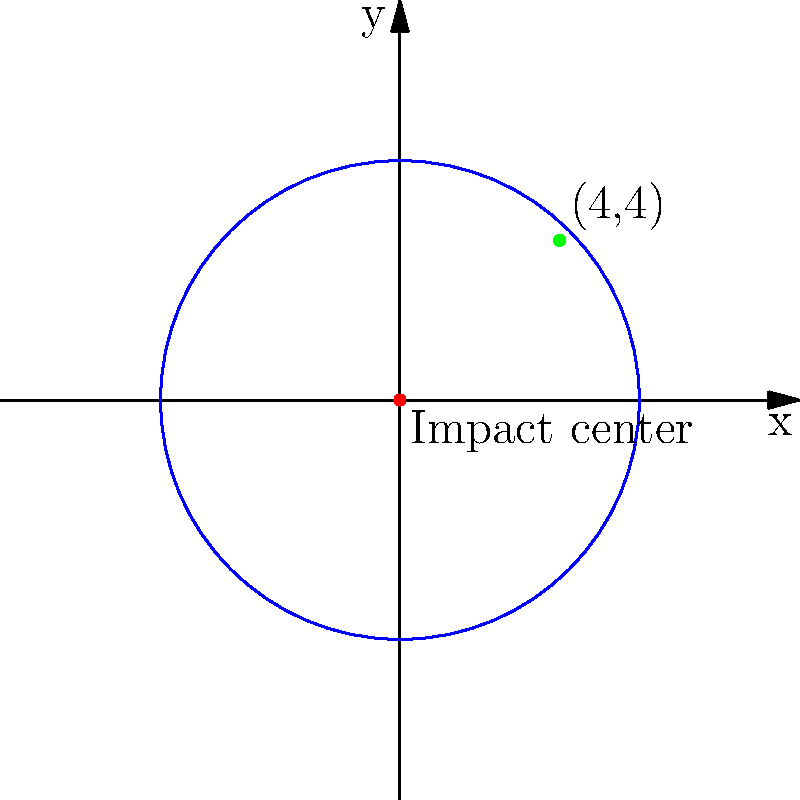A comet is predicted to impact Earth at the origin (0,0) of a 2D Cartesian coordinate system. The impact zone radius is estimated to be 6 units. If a critical infrastructure is located at coordinates (4,4), will it be within the impact zone? If so, by how many units is it inside the zone? To solve this problem, we need to follow these steps:

1) The impact zone is represented by a circle with radius 6 units centered at (0,0).

2) We need to determine if the point (4,4) is inside this circle.

3) To do this, we calculate the distance from (0,0) to (4,4) using the distance formula:

   $d = \sqrt{(x_2-x_1)^2 + (y_2-y_1)^2}$

4) Plugging in the values:
   
   $d = \sqrt{(4-0)^2 + (4-0)^2} = \sqrt{16 + 16} = \sqrt{32} \approx 5.66$

5) Since 5.66 < 6, the point (4,4) is inside the impact zone.

6) To determine how far inside the zone it is, we subtract this distance from the radius:

   $6 - 5.66 \approx 0.34$

Therefore, the critical infrastructure at (4,4) is within the impact zone, approximately 0.34 units inside the perimeter.
Answer: Yes, 0.34 units inside 